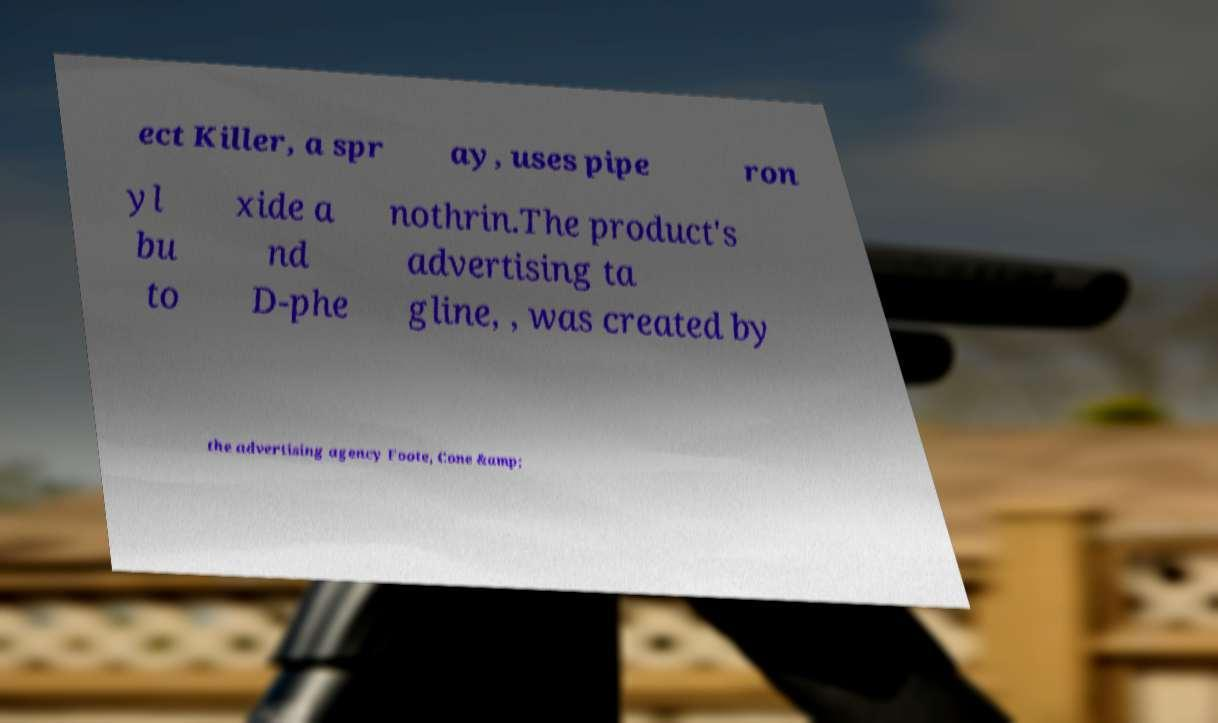Can you accurately transcribe the text from the provided image for me? ect Killer, a spr ay, uses pipe ron yl bu to xide a nd D-phe nothrin.The product's advertising ta gline, , was created by the advertising agency Foote, Cone &amp; 